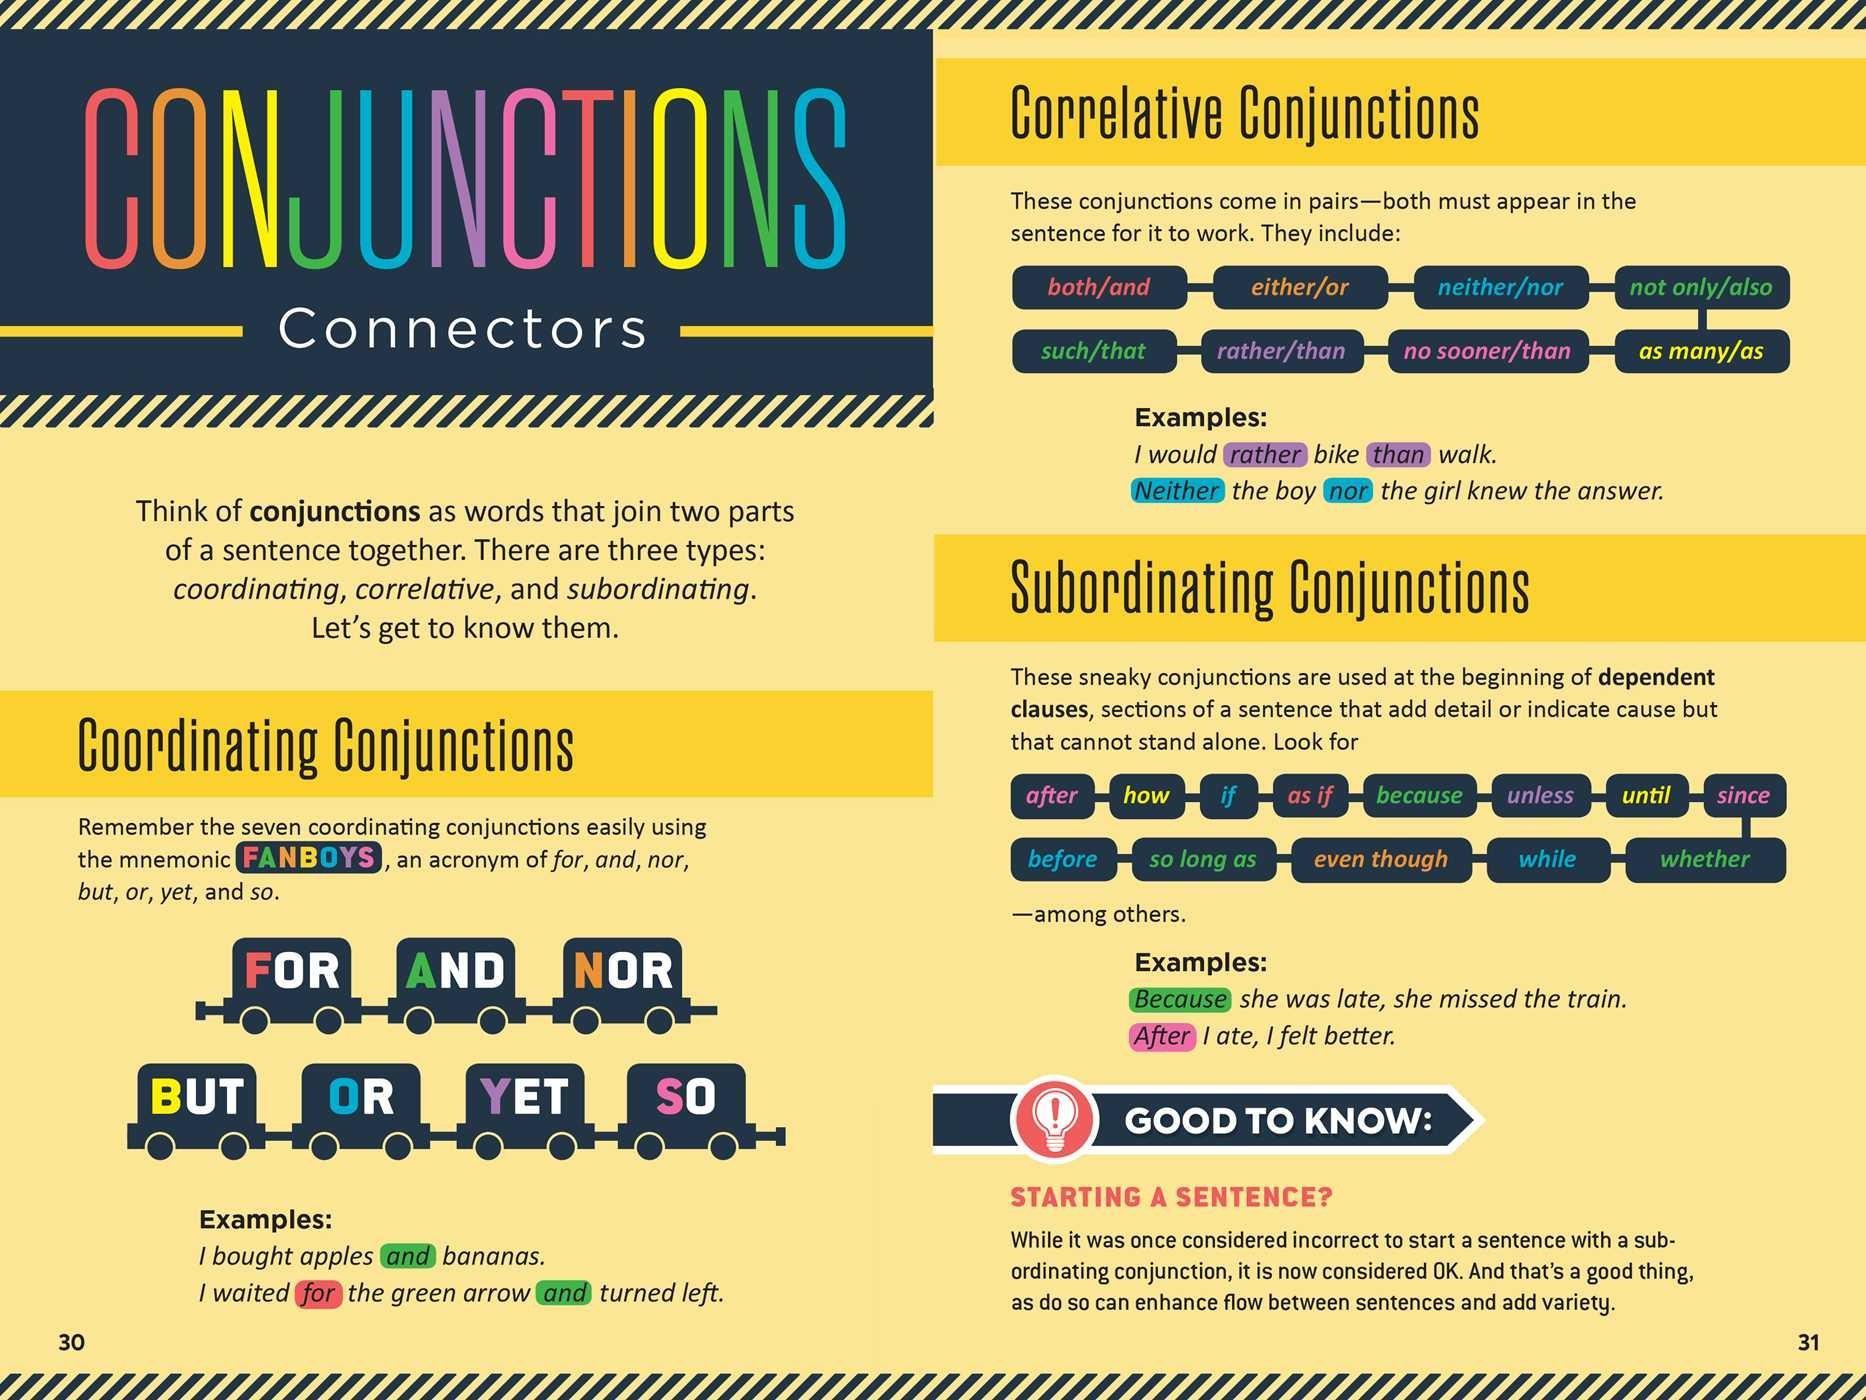"Even though" is an example of which kind of conjunction?
Answer the question with a short phrase. Subordinating Conjunctions What is the pair of correlative conjunction "both"? and Which type of Conjunction is "For"? Coordinating Which is the fourth "Coordinating Conjunctions" listed in the infographic? BUT Which type of Conjunction is "no sooner/than"? correlative Which type of Conjunction is "after", "how"? Subordinating Conjunctions What is the other name for "Conjunctions"? Connectors 